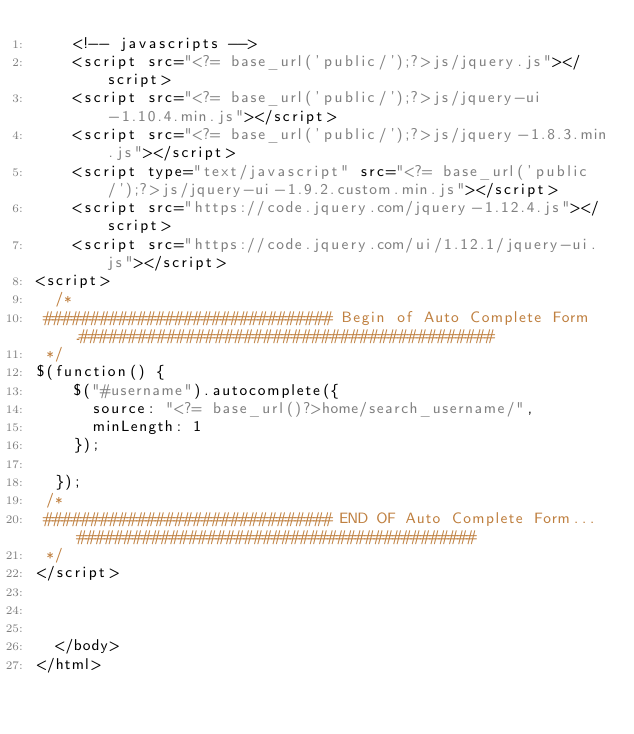Convert code to text. <code><loc_0><loc_0><loc_500><loc_500><_PHP_>    <!-- javascripts -->
    <script src="<?= base_url('public/');?>js/jquery.js"></script>
	<script src="<?= base_url('public/');?>js/jquery-ui-1.10.4.min.js"></script>
    <script src="<?= base_url('public/');?>js/jquery-1.8.3.min.js"></script>
    <script type="text/javascript" src="<?= base_url('public/');?>js/jquery-ui-1.9.2.custom.min.js"></script>
    <script src="https://code.jquery.com/jquery-1.12.4.js"></script>
    <script src="https://code.jquery.com/ui/1.12.1/jquery-ui.js"></script>
<script>
  /*
 ############################### Begin of Auto Complete Form ..###########################################
 */ 
$(function() {
    $("#username").autocomplete({
      source: "<?= base_url()?>home/search_username/",
      minLength: 1
    });

  });
 /*
 ############################### END OF Auto Complete Form... ###########################################
 */
</script>



  </body>
</html>
</code> 